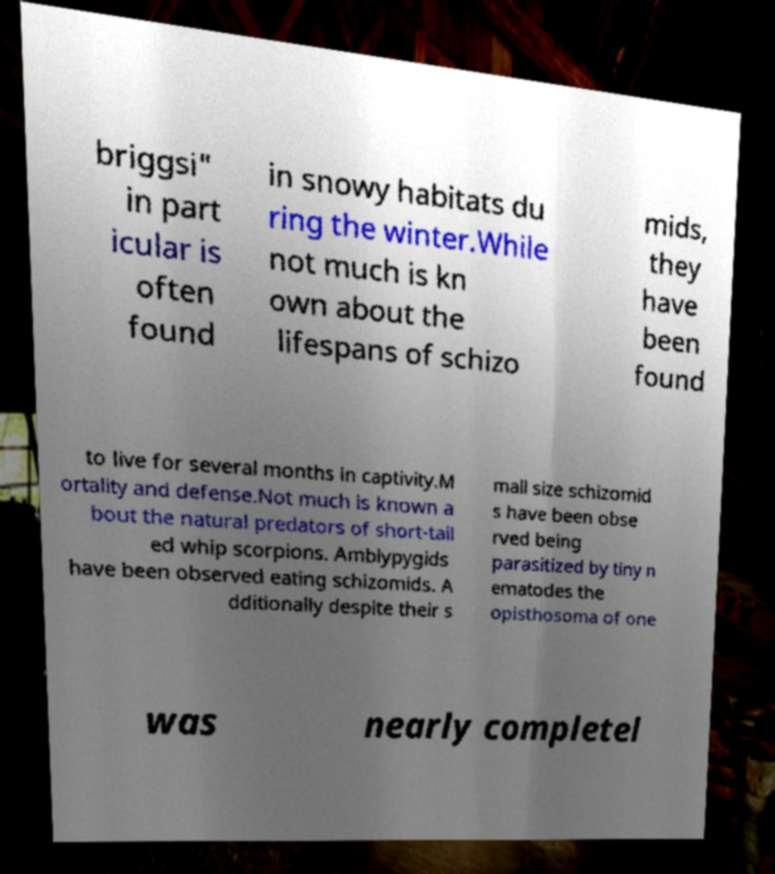I need the written content from this picture converted into text. Can you do that? briggsi" in part icular is often found in snowy habitats du ring the winter.While not much is kn own about the lifespans of schizo mids, they have been found to live for several months in captivity.M ortality and defense.Not much is known a bout the natural predators of short-tail ed whip scorpions. Amblypygids have been observed eating schizomids. A dditionally despite their s mall size schizomid s have been obse rved being parasitized by tiny n ematodes the opisthosoma of one was nearly completel 